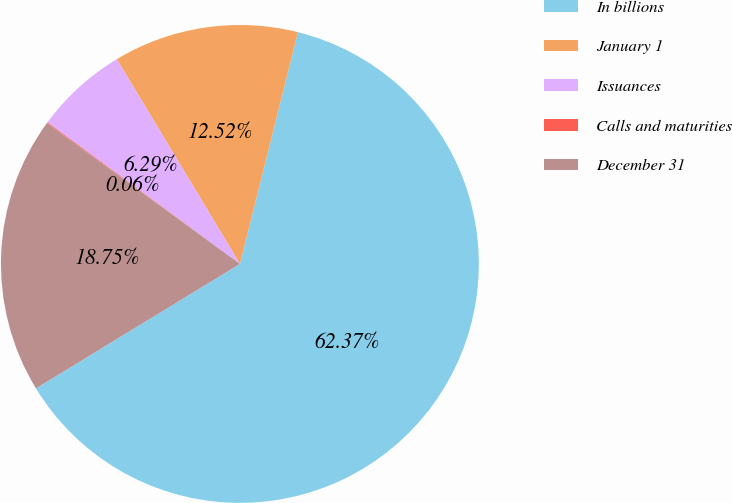Convert chart. <chart><loc_0><loc_0><loc_500><loc_500><pie_chart><fcel>In billions<fcel>January 1<fcel>Issuances<fcel>Calls and maturities<fcel>December 31<nl><fcel>62.36%<fcel>12.52%<fcel>6.29%<fcel>0.06%<fcel>18.75%<nl></chart> 